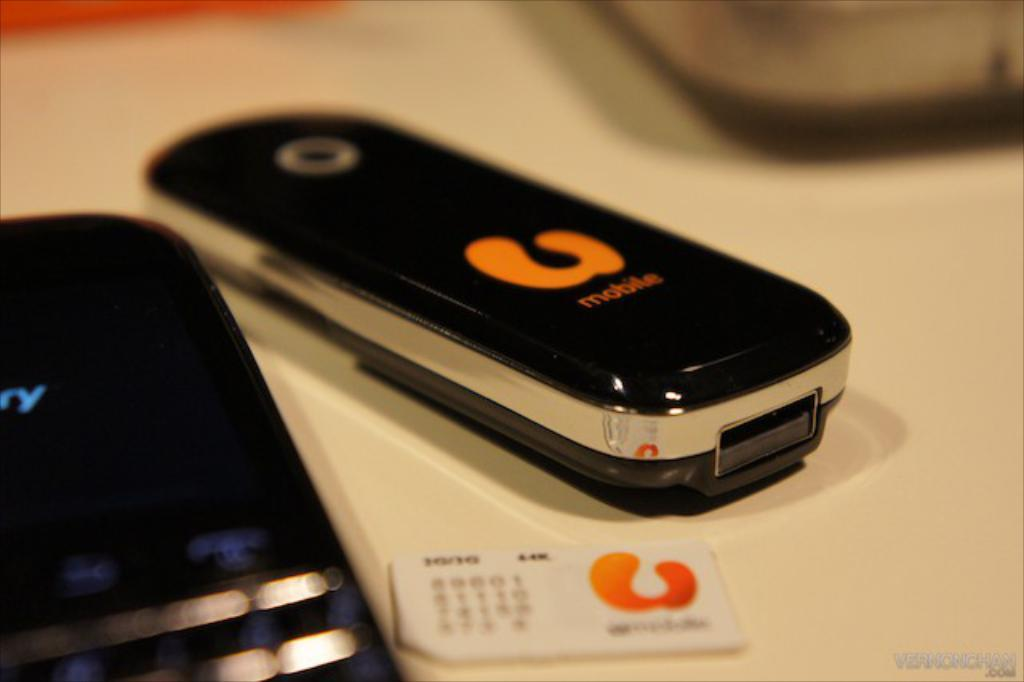Provide a one-sentence caption for the provided image. a U mobile phone is sitting on a table. 